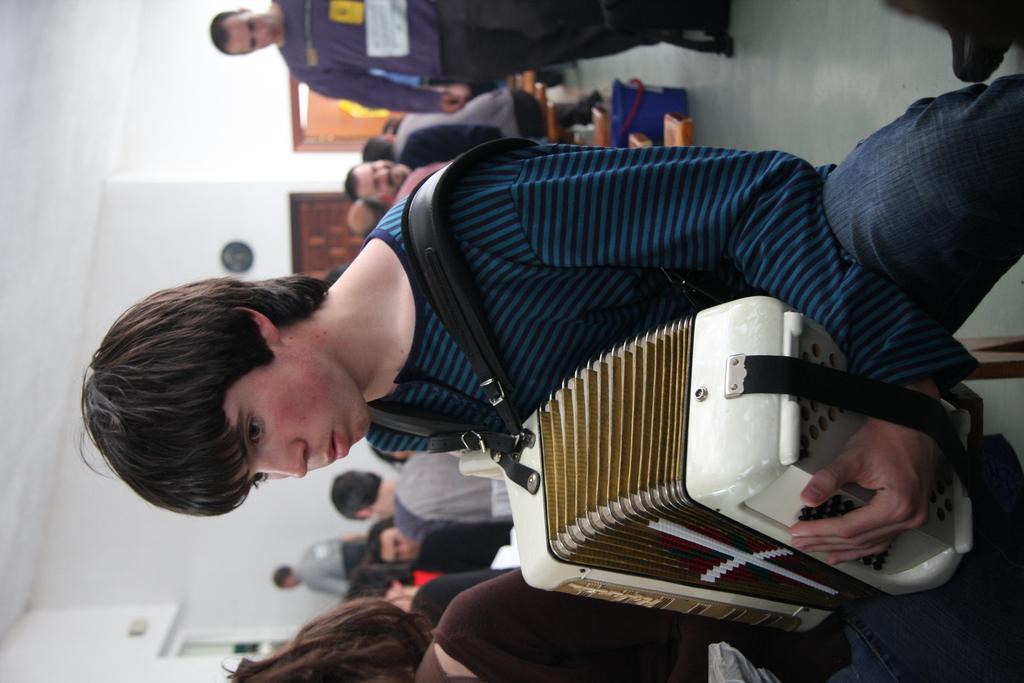How would you summarize this image in a sentence or two? In this image I can see a person holding a musical instrument, the person is wearing blue color shirt. Background I can see few other people some are sitting and some are standing, and I see few frames attached to the wall and the wall is white color. 